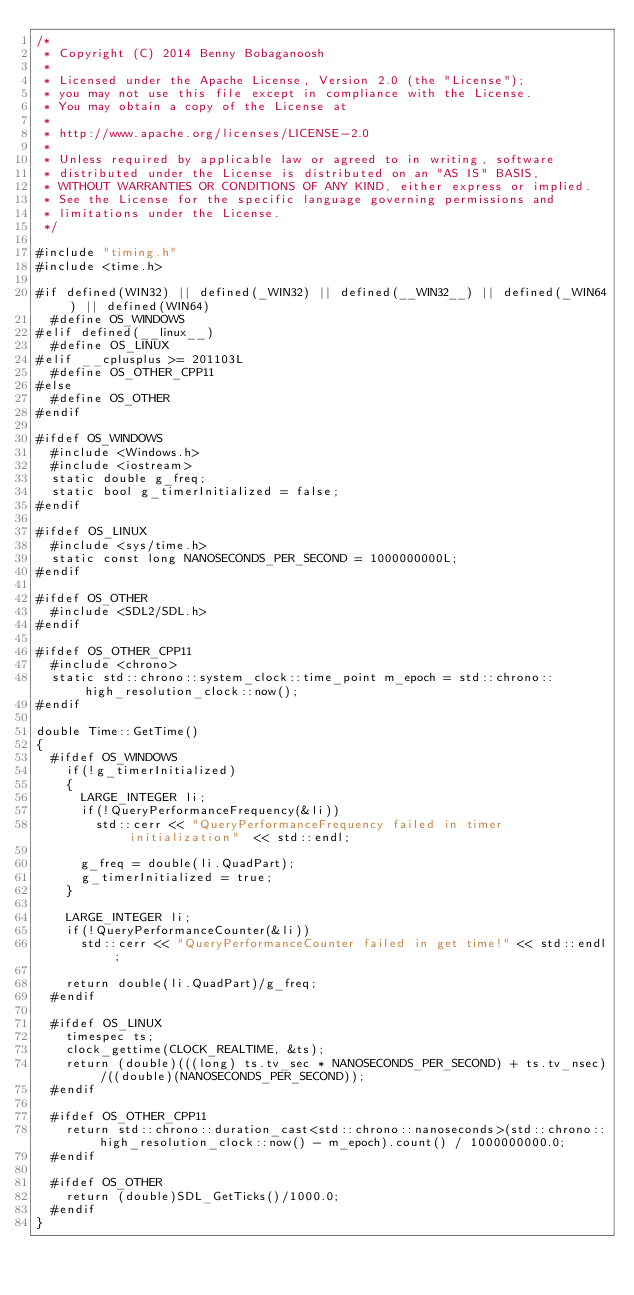Convert code to text. <code><loc_0><loc_0><loc_500><loc_500><_C++_>/*
 * Copyright (C) 2014 Benny Bobaganoosh
 *
 * Licensed under the Apache License, Version 2.0 (the "License");
 * you may not use this file except in compliance with the License.
 * You may obtain a copy of the License at
 *
 * http://www.apache.org/licenses/LICENSE-2.0
 *
 * Unless required by applicable law or agreed to in writing, software
 * distributed under the License is distributed on an "AS IS" BASIS,
 * WITHOUT WARRANTIES OR CONDITIONS OF ANY KIND, either express or implied.
 * See the License for the specific language governing permissions and
 * limitations under the License.
 */

#include "timing.h"
#include <time.h>

#if defined(WIN32) || defined(_WIN32) || defined(__WIN32__) || defined(_WIN64) || defined(WIN64)
	#define OS_WINDOWS
#elif defined(__linux__)
	#define OS_LINUX
#elif __cplusplus >= 201103L
	#define OS_OTHER_CPP11
#else
	#define OS_OTHER
#endif

#ifdef OS_WINDOWS
	#include <Windows.h>
	#include <iostream>
	static double g_freq;
	static bool g_timerInitialized = false;
#endif

#ifdef OS_LINUX
	#include <sys/time.h>
	static const long NANOSECONDS_PER_SECOND = 1000000000L;
#endif

#ifdef OS_OTHER
	#include <SDL2/SDL.h>
#endif

#ifdef OS_OTHER_CPP11
	#include <chrono>
	static std::chrono::system_clock::time_point m_epoch = std::chrono::high_resolution_clock::now();
#endif

double Time::GetTime()
{
	#ifdef OS_WINDOWS
		if(!g_timerInitialized)
		{
			LARGE_INTEGER li;
			if(!QueryPerformanceFrequency(&li))
				std::cerr << "QueryPerformanceFrequency failed in timer initialization"  << std::endl;
			
			g_freq = double(li.QuadPart);
			g_timerInitialized = true;
		}
	
		LARGE_INTEGER li;
		if(!QueryPerformanceCounter(&li))
			std::cerr << "QueryPerformanceCounter failed in get time!" << std::endl;
		
		return double(li.QuadPart)/g_freq;
	#endif

	#ifdef OS_LINUX
		timespec ts;
		clock_gettime(CLOCK_REALTIME, &ts);
		return (double)(((long) ts.tv_sec * NANOSECONDS_PER_SECOND) + ts.tv_nsec)/((double)(NANOSECONDS_PER_SECOND));
	#endif

	#ifdef OS_OTHER_CPP11
		return std::chrono::duration_cast<std::chrono::nanoseconds>(std::chrono::high_resolution_clock::now() - m_epoch).count() / 1000000000.0;
	#endif

	#ifdef OS_OTHER
		return (double)SDL_GetTicks()/1000.0;
	#endif
}
</code> 